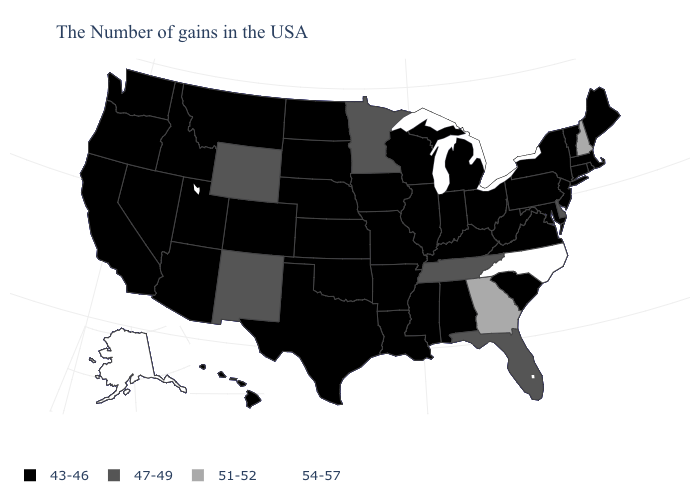Which states hav the highest value in the MidWest?
Quick response, please. Minnesota. How many symbols are there in the legend?
Keep it brief. 4. Does the map have missing data?
Quick response, please. No. Name the states that have a value in the range 54-57?
Short answer required. North Carolina, Alaska. What is the value of Idaho?
Write a very short answer. 43-46. Does Montana have the same value as Connecticut?
Quick response, please. Yes. Name the states that have a value in the range 54-57?
Be succinct. North Carolina, Alaska. What is the lowest value in the Northeast?
Quick response, please. 43-46. What is the value of Maryland?
Quick response, please. 43-46. Which states have the highest value in the USA?
Concise answer only. North Carolina, Alaska. Which states have the lowest value in the USA?
Give a very brief answer. Maine, Massachusetts, Rhode Island, Vermont, Connecticut, New York, New Jersey, Maryland, Pennsylvania, Virginia, South Carolina, West Virginia, Ohio, Michigan, Kentucky, Indiana, Alabama, Wisconsin, Illinois, Mississippi, Louisiana, Missouri, Arkansas, Iowa, Kansas, Nebraska, Oklahoma, Texas, South Dakota, North Dakota, Colorado, Utah, Montana, Arizona, Idaho, Nevada, California, Washington, Oregon, Hawaii. Name the states that have a value in the range 54-57?
Be succinct. North Carolina, Alaska. Name the states that have a value in the range 51-52?
Concise answer only. New Hampshire, Georgia. Does Nebraska have a higher value than Florida?
Write a very short answer. No. 